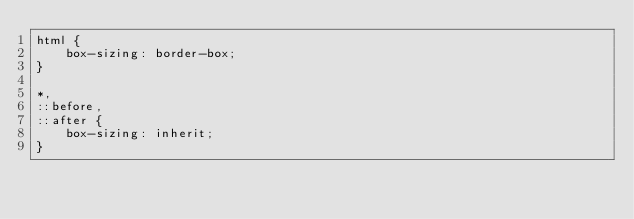Convert code to text. <code><loc_0><loc_0><loc_500><loc_500><_CSS_>html {
    box-sizing: border-box;
}

*,
::before,
::after {
    box-sizing: inherit;
}</code> 